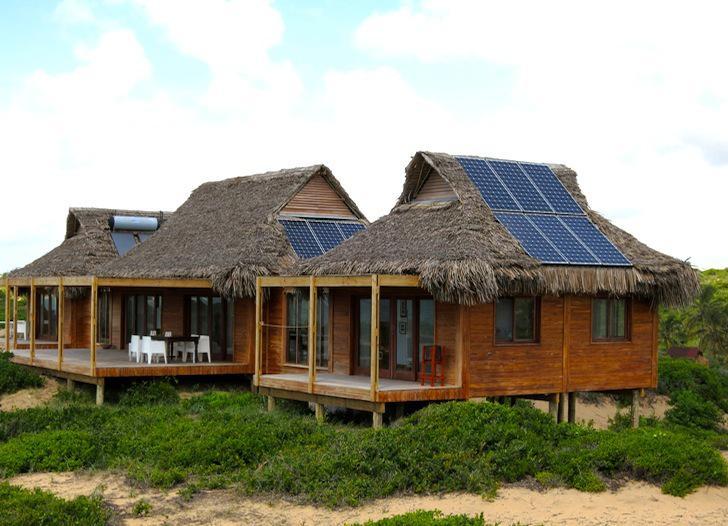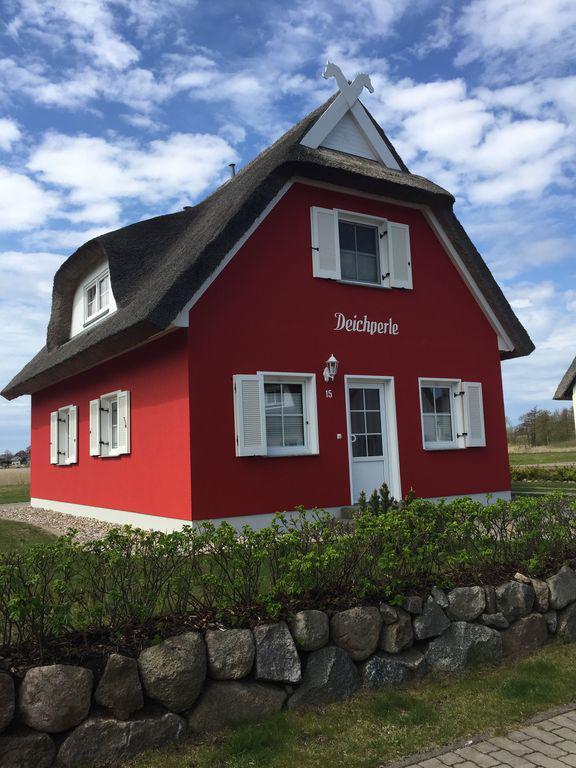The first image is the image on the left, the second image is the image on the right. Considering the images on both sides, is "There are at least four chimney on a total of two building with at least one being white." valid? Answer yes or no. No. The first image is the image on the left, the second image is the image on the right. Evaluate the accuracy of this statement regarding the images: "In the right image at least two chimneys are visible.". Is it true? Answer yes or no. No. 